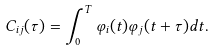<formula> <loc_0><loc_0><loc_500><loc_500>C _ { i j } ( \tau ) = \int _ { 0 } ^ { T } \varphi _ { i } ( t ) \varphi _ { j } ( t + \tau ) d t .</formula> 